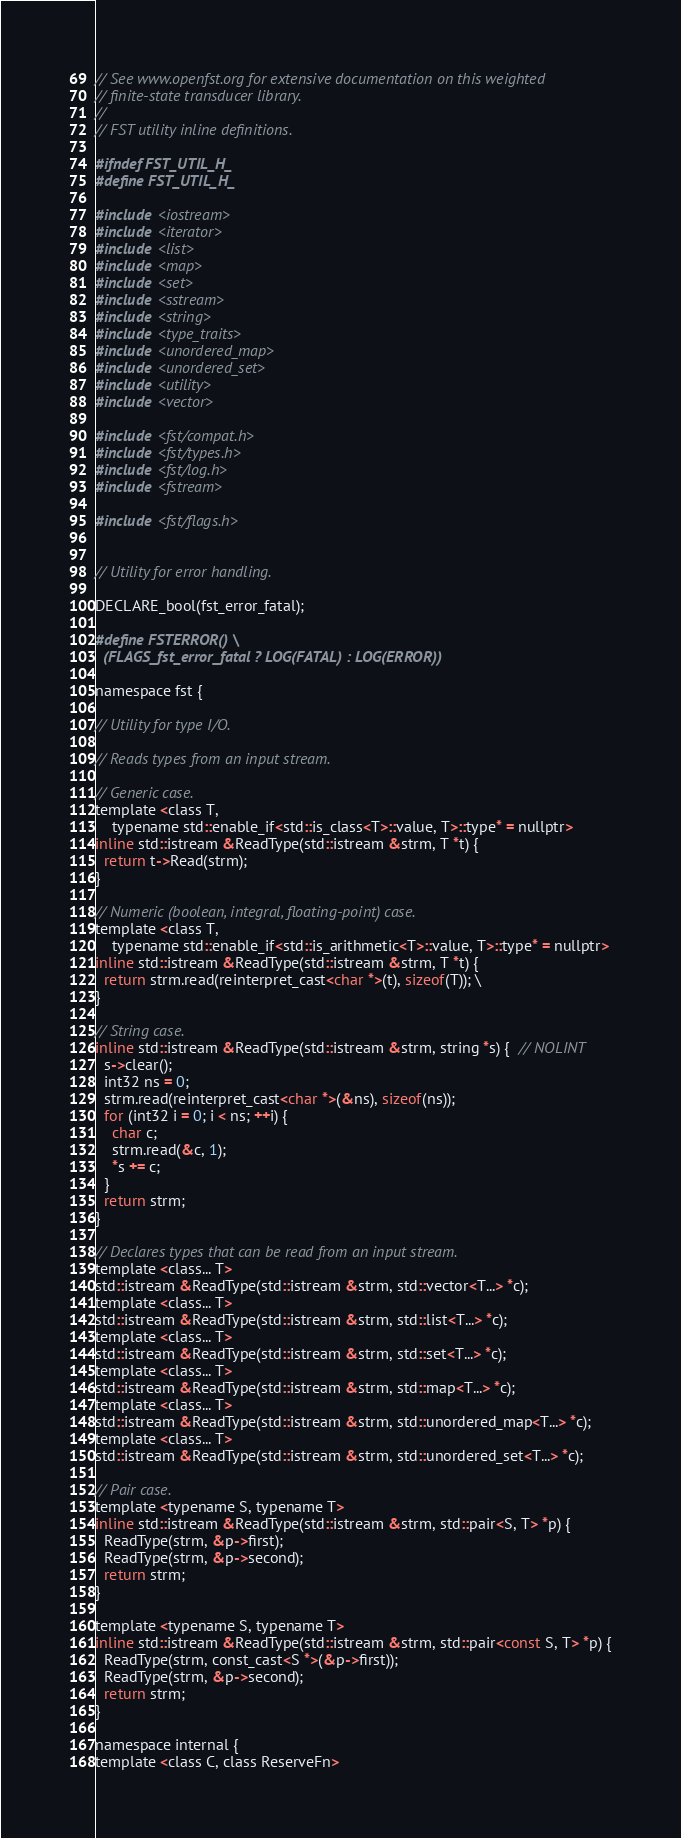<code> <loc_0><loc_0><loc_500><loc_500><_C_>// See www.openfst.org for extensive documentation on this weighted
// finite-state transducer library.
//
// FST utility inline definitions.

#ifndef FST_UTIL_H_
#define FST_UTIL_H_

#include <iostream>
#include <iterator>
#include <list>
#include <map>
#include <set>
#include <sstream>
#include <string>
#include <type_traits>
#include <unordered_map>
#include <unordered_set>
#include <utility>
#include <vector>

#include <fst/compat.h>
#include <fst/types.h>
#include <fst/log.h>
#include <fstream>

#include <fst/flags.h>


// Utility for error handling.

DECLARE_bool(fst_error_fatal);

#define FSTERROR() \
  (FLAGS_fst_error_fatal ? LOG(FATAL) : LOG(ERROR))

namespace fst {

// Utility for type I/O.

// Reads types from an input stream.

// Generic case.
template <class T,
    typename std::enable_if<std::is_class<T>::value, T>::type* = nullptr>
inline std::istream &ReadType(std::istream &strm, T *t) {
  return t->Read(strm);
}

// Numeric (boolean, integral, floating-point) case.
template <class T,
    typename std::enable_if<std::is_arithmetic<T>::value, T>::type* = nullptr>
inline std::istream &ReadType(std::istream &strm, T *t) {
  return strm.read(reinterpret_cast<char *>(t), sizeof(T)); \
}

// String case.
inline std::istream &ReadType(std::istream &strm, string *s) {  // NOLINT
  s->clear();
  int32 ns = 0;
  strm.read(reinterpret_cast<char *>(&ns), sizeof(ns));
  for (int32 i = 0; i < ns; ++i) {
    char c;
    strm.read(&c, 1);
    *s += c;
  }
  return strm;
}

// Declares types that can be read from an input stream.
template <class... T>
std::istream &ReadType(std::istream &strm, std::vector<T...> *c);
template <class... T>
std::istream &ReadType(std::istream &strm, std::list<T...> *c);
template <class... T>
std::istream &ReadType(std::istream &strm, std::set<T...> *c);
template <class... T>
std::istream &ReadType(std::istream &strm, std::map<T...> *c);
template <class... T>
std::istream &ReadType(std::istream &strm, std::unordered_map<T...> *c);
template <class... T>
std::istream &ReadType(std::istream &strm, std::unordered_set<T...> *c);

// Pair case.
template <typename S, typename T>
inline std::istream &ReadType(std::istream &strm, std::pair<S, T> *p) {
  ReadType(strm, &p->first);
  ReadType(strm, &p->second);
  return strm;
}

template <typename S, typename T>
inline std::istream &ReadType(std::istream &strm, std::pair<const S, T> *p) {
  ReadType(strm, const_cast<S *>(&p->first));
  ReadType(strm, &p->second);
  return strm;
}

namespace internal {
template <class C, class ReserveFn></code> 